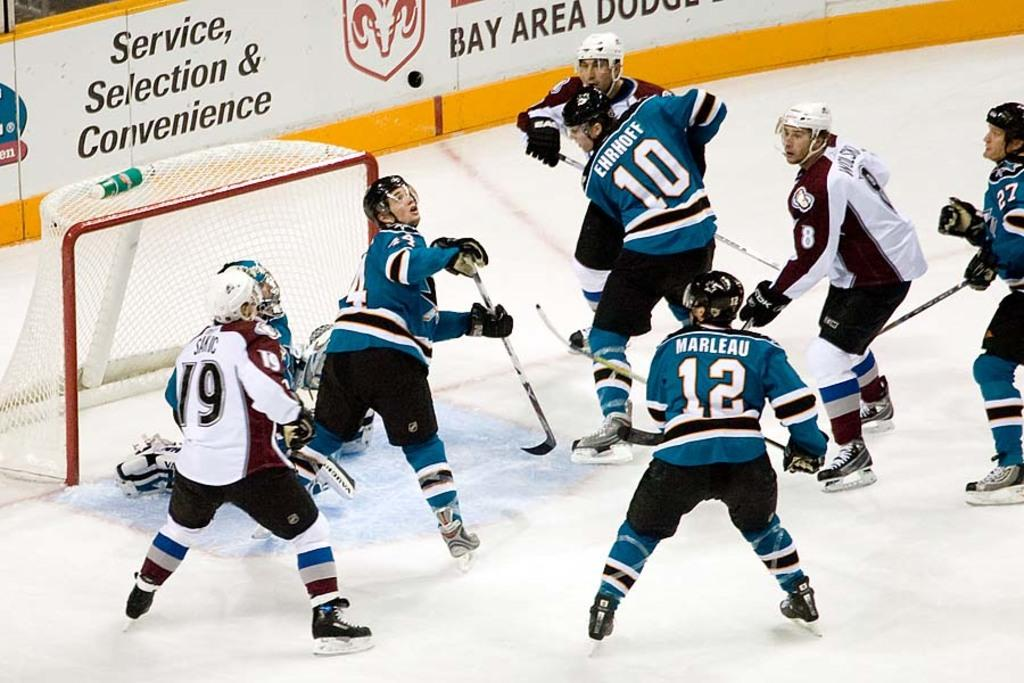<image>
Describe the image concisely. Hockey players by the goal with a banner from Bay Area Dodge on the wall. 